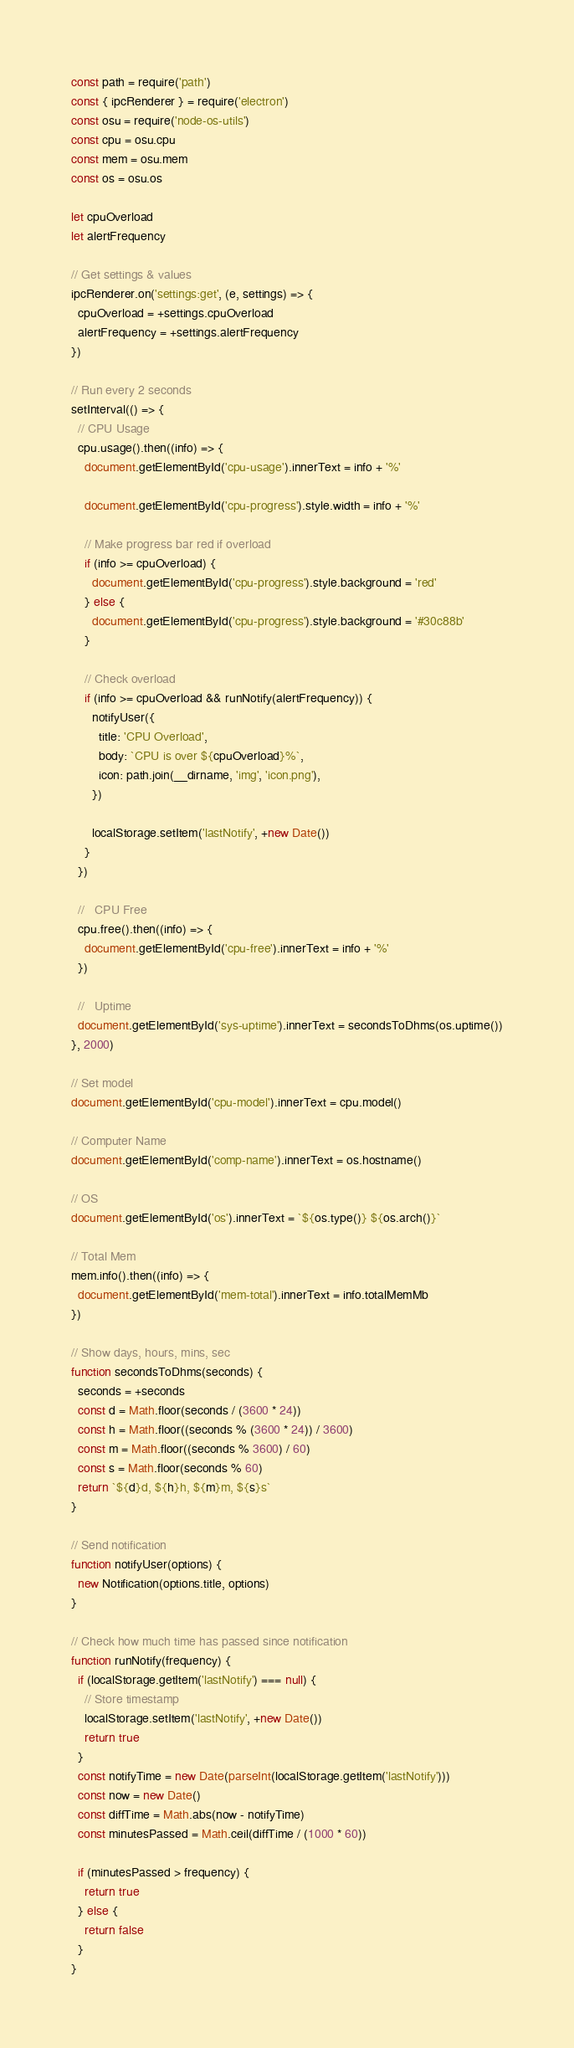Convert code to text. <code><loc_0><loc_0><loc_500><loc_500><_JavaScript_>const path = require('path')
const { ipcRenderer } = require('electron')
const osu = require('node-os-utils')
const cpu = osu.cpu
const mem = osu.mem
const os = osu.os

let cpuOverload
let alertFrequency

// Get settings & values
ipcRenderer.on('settings:get', (e, settings) => {
  cpuOverload = +settings.cpuOverload
  alertFrequency = +settings.alertFrequency
})

// Run every 2 seconds
setInterval(() => {
  // CPU Usage
  cpu.usage().then((info) => {
    document.getElementById('cpu-usage').innerText = info + '%'

    document.getElementById('cpu-progress').style.width = info + '%'

    // Make progress bar red if overload
    if (info >= cpuOverload) {
      document.getElementById('cpu-progress').style.background = 'red'
    } else {
      document.getElementById('cpu-progress').style.background = '#30c88b'
    }

    // Check overload
    if (info >= cpuOverload && runNotify(alertFrequency)) {
      notifyUser({
        title: 'CPU Overload',
        body: `CPU is over ${cpuOverload}%`,
        icon: path.join(__dirname, 'img', 'icon.png'),
      })

      localStorage.setItem('lastNotify', +new Date())
    }
  })

  //   CPU Free
  cpu.free().then((info) => {
    document.getElementById('cpu-free').innerText = info + '%'
  })

  //   Uptime
  document.getElementById('sys-uptime').innerText = secondsToDhms(os.uptime())
}, 2000)

// Set model
document.getElementById('cpu-model').innerText = cpu.model()

// Computer Name
document.getElementById('comp-name').innerText = os.hostname()

// OS
document.getElementById('os').innerText = `${os.type()} ${os.arch()}`

// Total Mem
mem.info().then((info) => {
  document.getElementById('mem-total').innerText = info.totalMemMb
})

// Show days, hours, mins, sec
function secondsToDhms(seconds) {
  seconds = +seconds
  const d = Math.floor(seconds / (3600 * 24))
  const h = Math.floor((seconds % (3600 * 24)) / 3600)
  const m = Math.floor((seconds % 3600) / 60)
  const s = Math.floor(seconds % 60)
  return `${d}d, ${h}h, ${m}m, ${s}s`
}

// Send notification
function notifyUser(options) {
  new Notification(options.title, options)
}

// Check how much time has passed since notification
function runNotify(frequency) {
  if (localStorage.getItem('lastNotify') === null) {
    // Store timestamp
    localStorage.setItem('lastNotify', +new Date())
    return true
  }
  const notifyTime = new Date(parseInt(localStorage.getItem('lastNotify')))
  const now = new Date()
  const diffTime = Math.abs(now - notifyTime)
  const minutesPassed = Math.ceil(diffTime / (1000 * 60))

  if (minutesPassed > frequency) {
    return true
  } else {
    return false
  }
}
</code> 